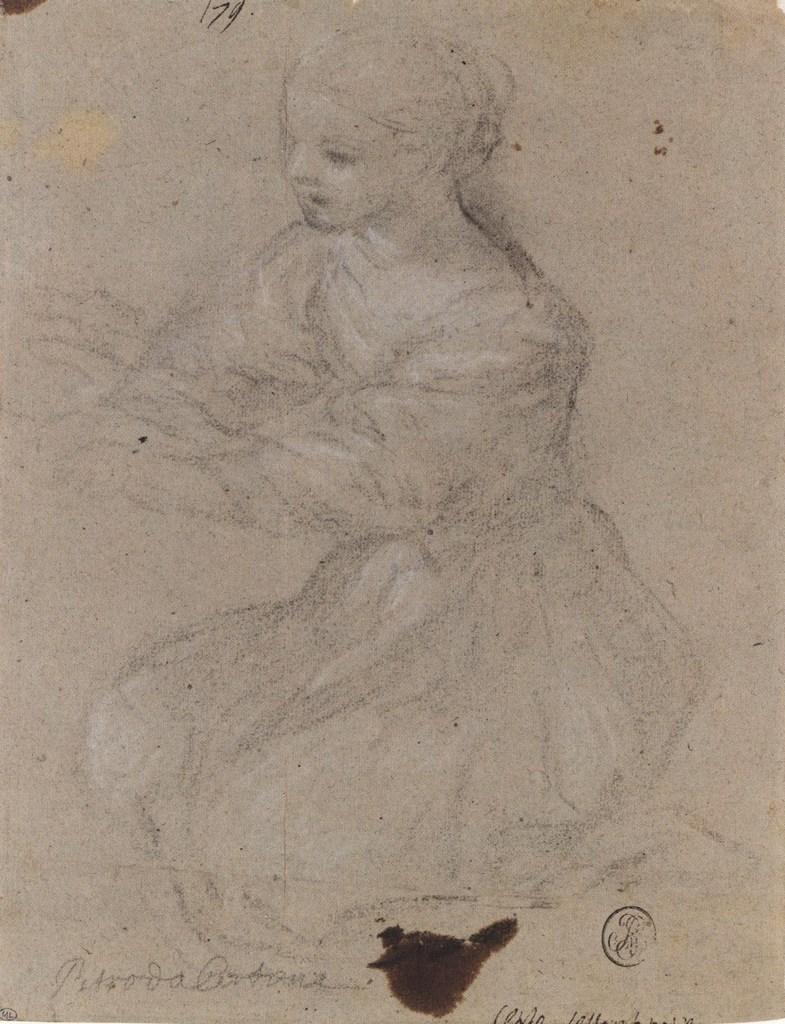In one or two sentences, can you explain what this image depicts? In the center of the image we can see one paper. On the paper,we can see some drawing,in which we can see one woman. And we can see some text on the paper. 